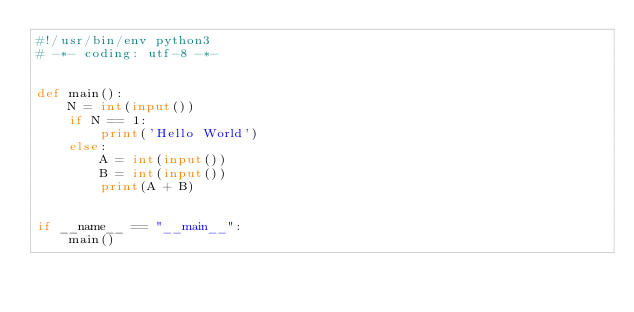<code> <loc_0><loc_0><loc_500><loc_500><_Python_>#!/usr/bin/env python3
# -*- coding: utf-8 -*-


def main():
    N = int(input())
    if N == 1:
        print('Hello World')
    else:
        A = int(input())
        B = int(input())
        print(A + B)


if __name__ == "__main__":
    main()
</code> 